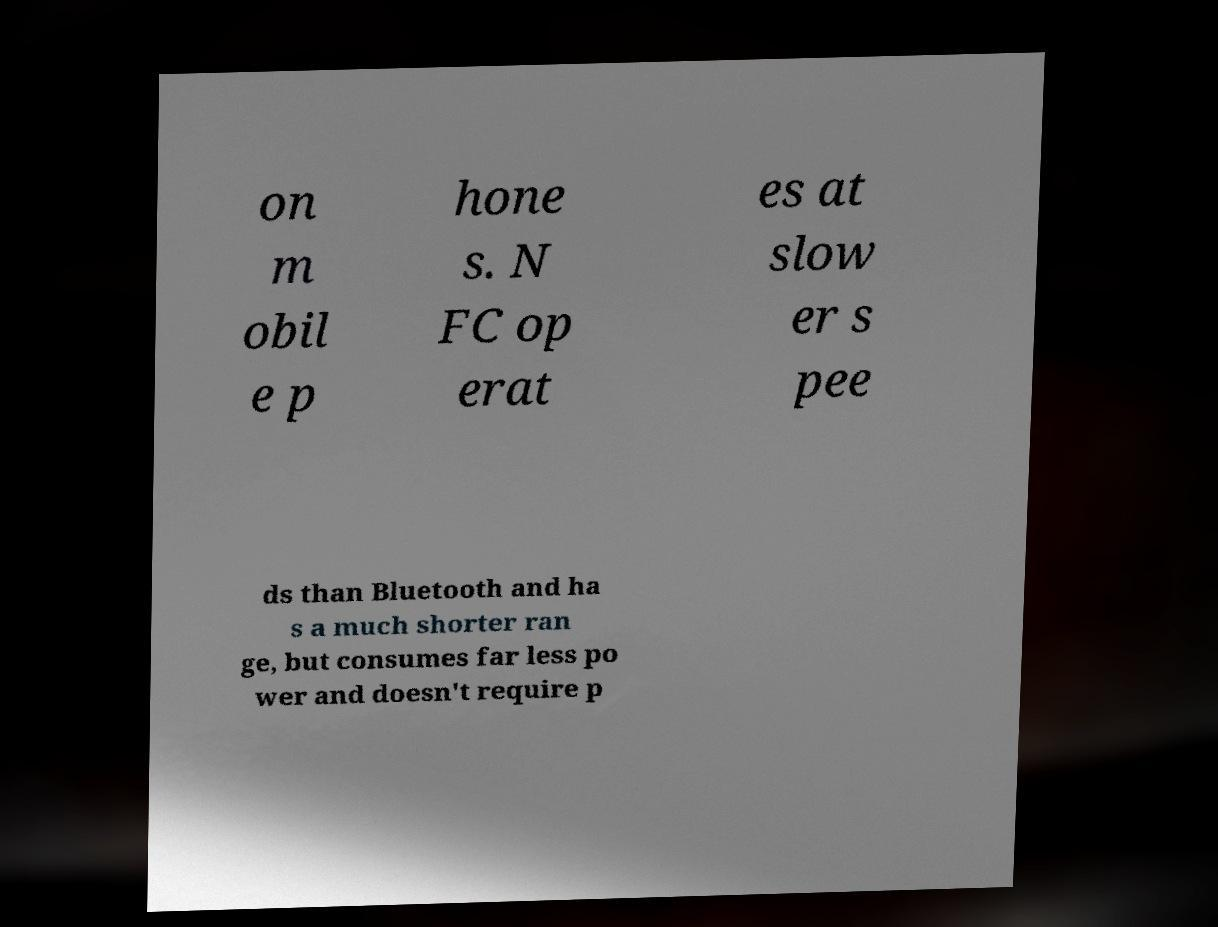Please identify and transcribe the text found in this image. on m obil e p hone s. N FC op erat es at slow er s pee ds than Bluetooth and ha s a much shorter ran ge, but consumes far less po wer and doesn't require p 